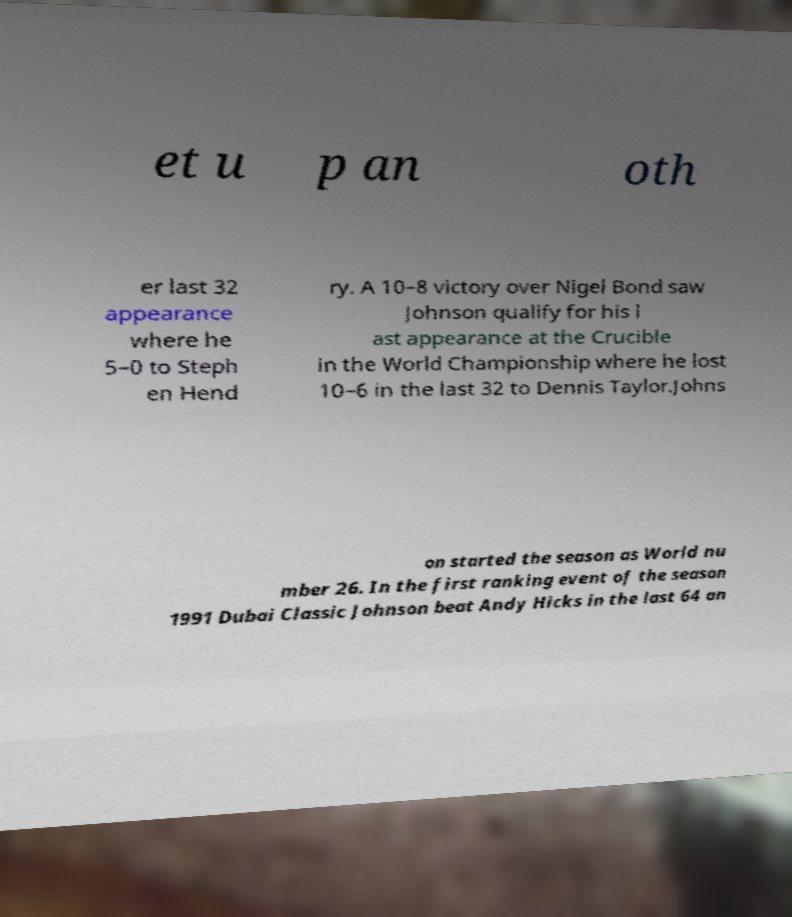Could you extract and type out the text from this image? et u p an oth er last 32 appearance where he 5–0 to Steph en Hend ry. A 10–8 victory over Nigel Bond saw Johnson qualify for his l ast appearance at the Crucible in the World Championship where he lost 10–6 in the last 32 to Dennis Taylor.Johns on started the season as World nu mber 26. In the first ranking event of the season 1991 Dubai Classic Johnson beat Andy Hicks in the last 64 an 